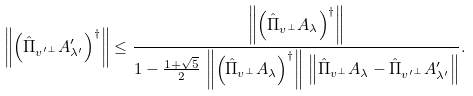<formula> <loc_0><loc_0><loc_500><loc_500>\left \| \left ( \hat { \Pi } _ { { v ^ { \prime } } ^ { \perp } } A ^ { \prime } _ { \lambda ^ { \prime } } \right ) ^ { \dagger } \right \| \leq \frac { \left \| \left ( \hat { \Pi } _ { v ^ { \perp } } A _ { \lambda } \right ) ^ { \dagger } \right \| } { 1 - \frac { 1 + \sqrt { 5 } } { 2 } \, \left \| \left ( \hat { \Pi } _ { v ^ { \perp } } A _ { \lambda } \right ) ^ { \dagger } \right \| \, \left \| { \hat { \Pi } _ { v ^ { \perp } } A _ { \lambda } - \hat { \Pi } _ { { v ^ { \prime } } ^ { \perp } } A ^ { \prime } _ { \lambda ^ { \prime } } } \right \| } .</formula> 